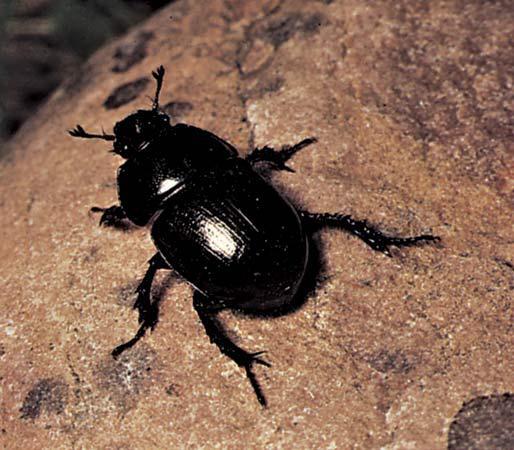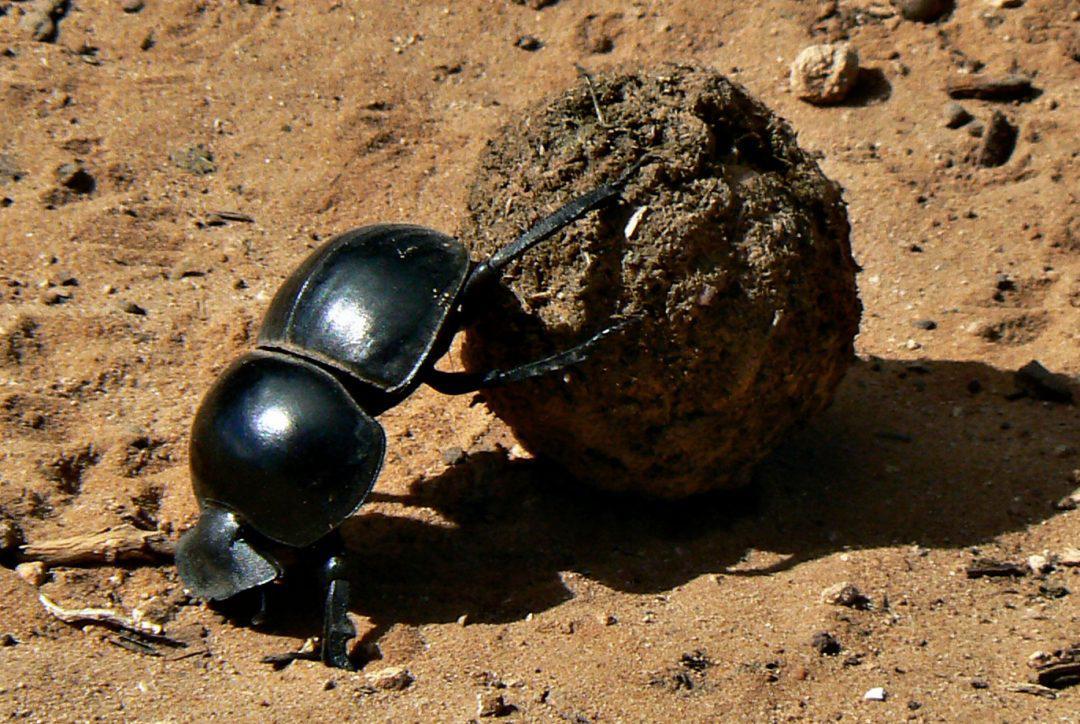The first image is the image on the left, the second image is the image on the right. For the images displayed, is the sentence "The right image contains a dung ball." factually correct? Answer yes or no. Yes. 